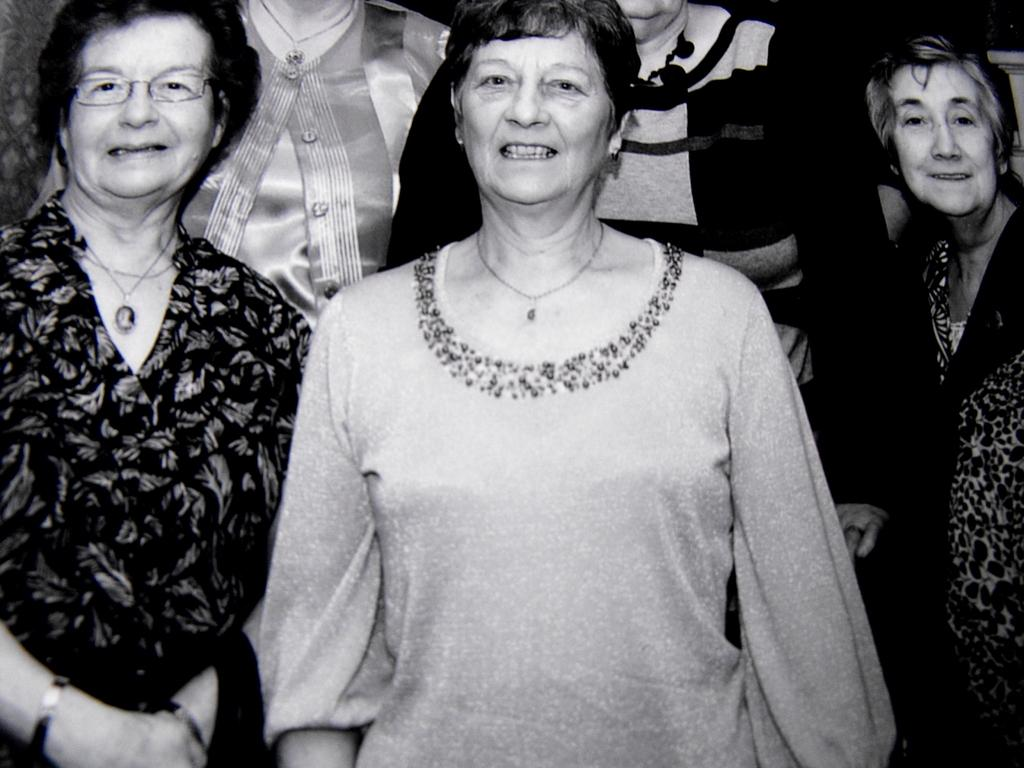What is the color scheme of the image? The image is black and white. How many ladies are present in the image? There are five ladies in the image. What are the ladies doing in the image? The ladies are standing. What are the ladies wearing in the image? The ladies are wearing dresses. Where is the mask placed in the image? There is no mask present in the image. What type of cub can be seen interacting with the ladies in the image? There is no cub present in the image; the ladies are the only subjects visible. 